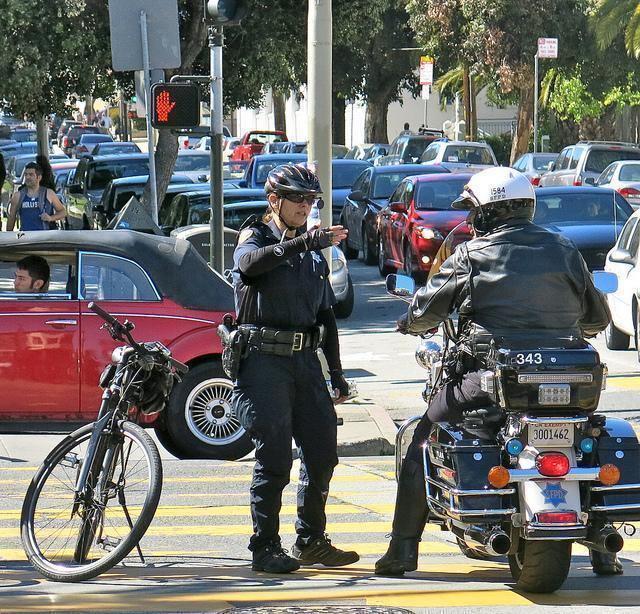What are they discussing?
From the following four choices, select the correct answer to address the question.
Options: Traffic, gas cost, plans date, gun cost. Traffic. 